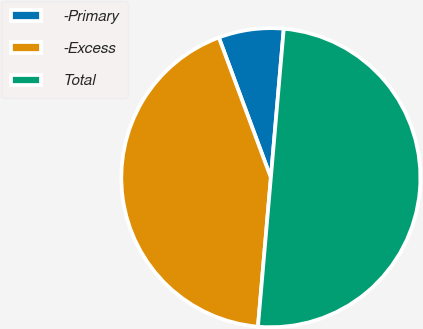Convert chart to OTSL. <chart><loc_0><loc_0><loc_500><loc_500><pie_chart><fcel>-Primary<fcel>-Excess<fcel>Total<nl><fcel>7.03%<fcel>42.97%<fcel>50.0%<nl></chart> 